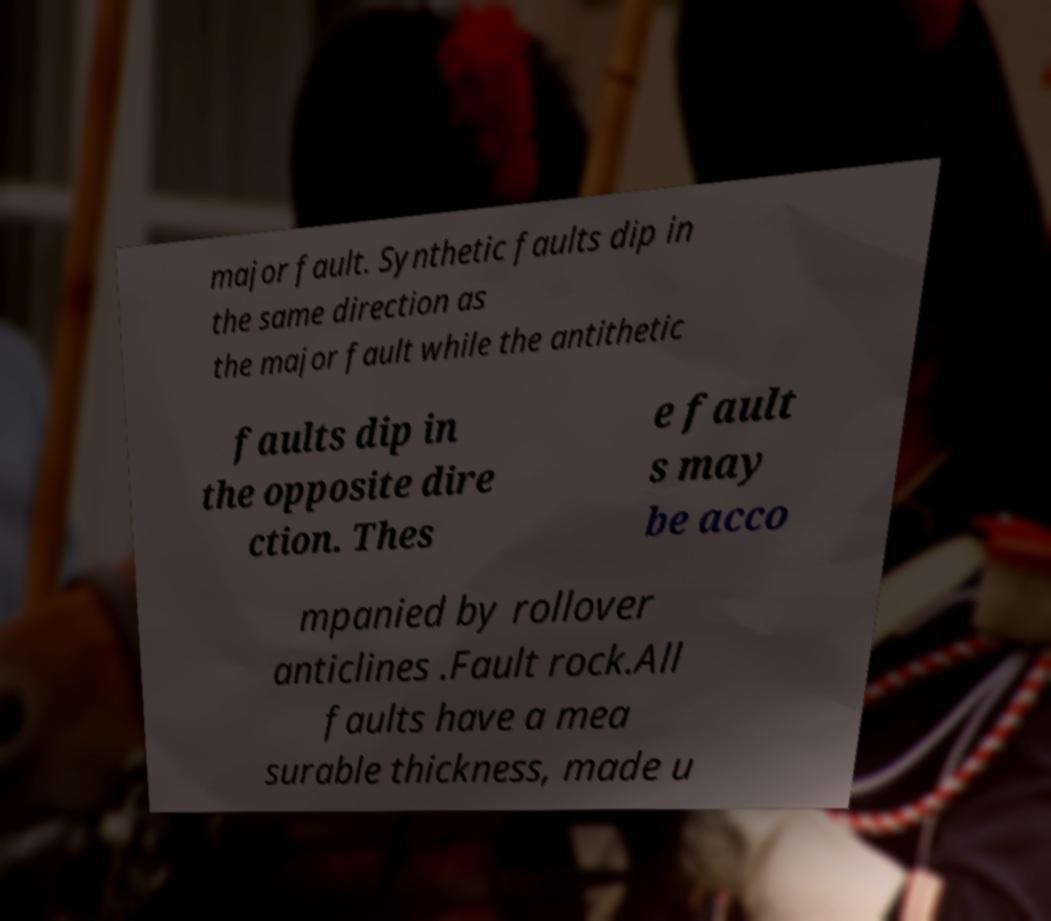I need the written content from this picture converted into text. Can you do that? major fault. Synthetic faults dip in the same direction as the major fault while the antithetic faults dip in the opposite dire ction. Thes e fault s may be acco mpanied by rollover anticlines .Fault rock.All faults have a mea surable thickness, made u 